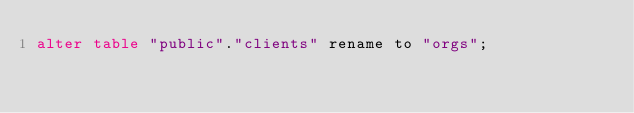Convert code to text. <code><loc_0><loc_0><loc_500><loc_500><_SQL_>alter table "public"."clients" rename to "orgs";
</code> 